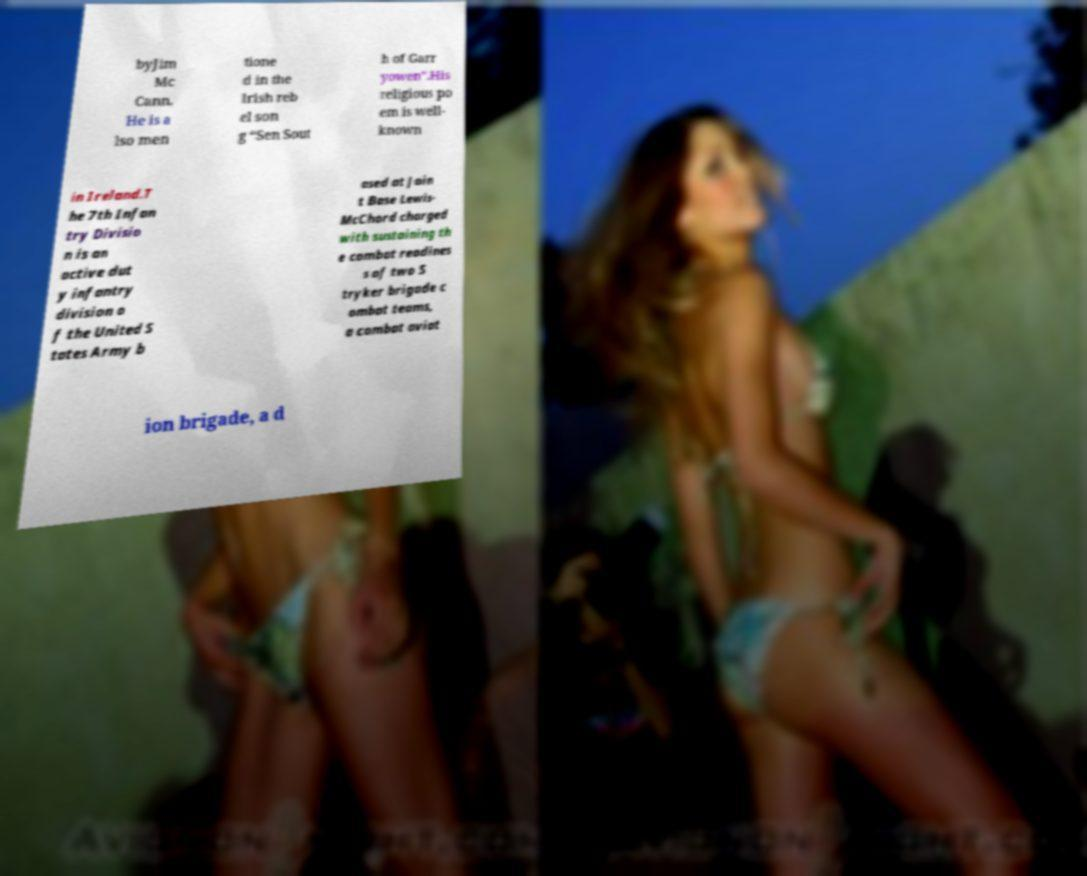I need the written content from this picture converted into text. Can you do that? byJim Mc Cann. He is a lso men tione d in the Irish reb el son g “Sen Sout h of Garr yowen”.His religious po em is well- known in Ireland.T he 7th Infan try Divisio n is an active dut y infantry division o f the United S tates Army b ased at Join t Base Lewis- McChord charged with sustaining th e combat readines s of two S tryker brigade c ombat teams, a combat aviat ion brigade, a d 